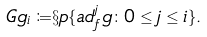<formula> <loc_0><loc_0><loc_500><loc_500>\ G g _ { i } \coloneqq & \S p \{ a d ^ { j } _ { f } g \colon 0 \leq j \leq i \} .</formula> 